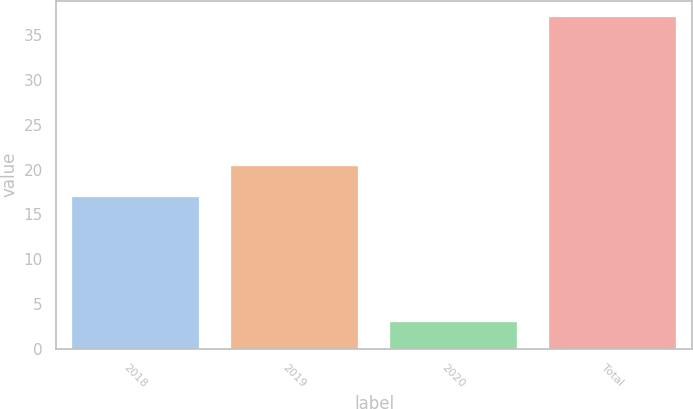<chart> <loc_0><loc_0><loc_500><loc_500><bar_chart><fcel>2018<fcel>2019<fcel>2020<fcel>Total<nl><fcel>17<fcel>20.4<fcel>3<fcel>37<nl></chart> 